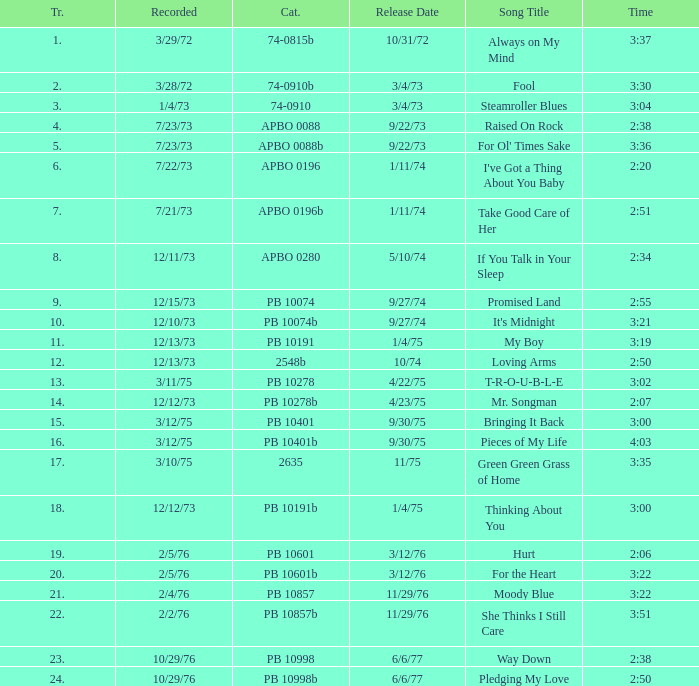Tell me the track that has the catalogue of apbo 0280 8.0. 